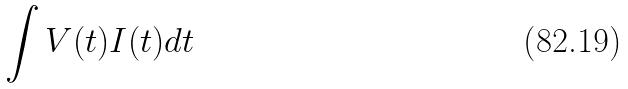Convert formula to latex. <formula><loc_0><loc_0><loc_500><loc_500>\int V ( t ) I ( t ) d t</formula> 